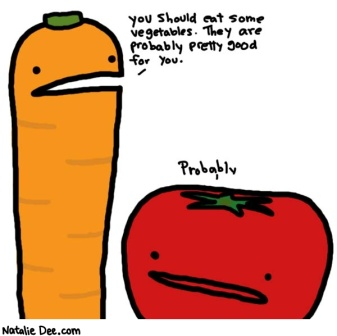Can you describe the personality of each vegetable based on their expressions? The carrot, with its orange hue and green top, appears to have a somewhat authoritative and earnest personality, as suggested by its frowning face and the authoritative suggestion to eat vegetables. The tomato, on the other hand, seems more laid-back and slightly skeptical, as indicated by its mirrored frown and the word 'Probably' beneath it. Together, they create a dynamic duo of seriousness and casual doubt, adding to the cartoon's humor. 